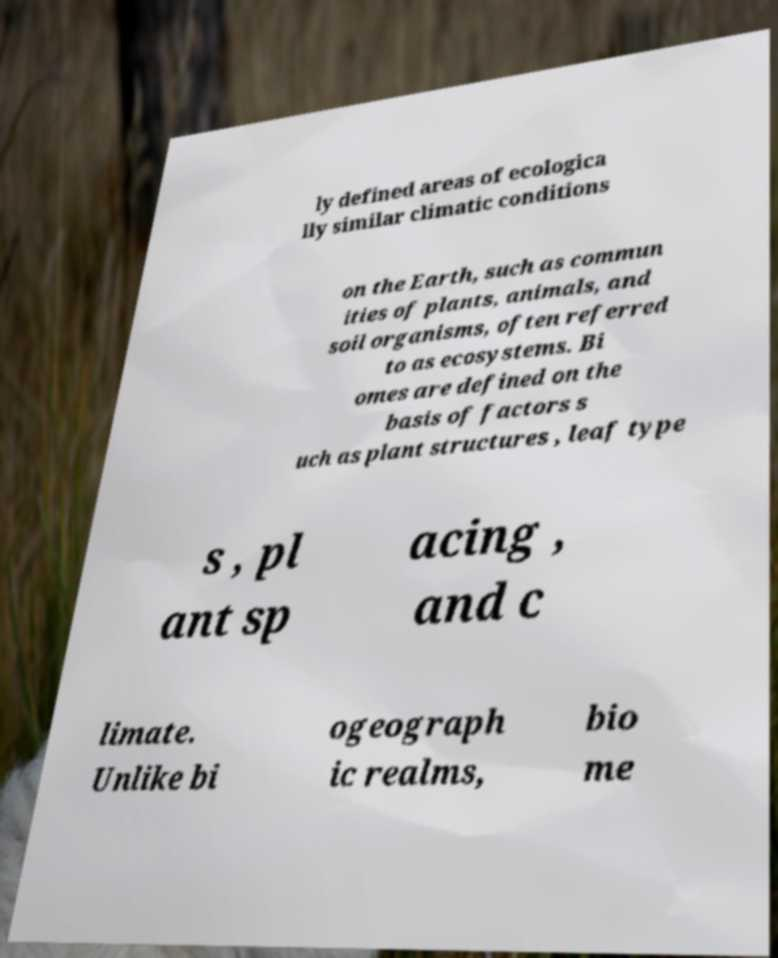Could you extract and type out the text from this image? ly defined areas of ecologica lly similar climatic conditions on the Earth, such as commun ities of plants, animals, and soil organisms, often referred to as ecosystems. Bi omes are defined on the basis of factors s uch as plant structures , leaf type s , pl ant sp acing , and c limate. Unlike bi ogeograph ic realms, bio me 